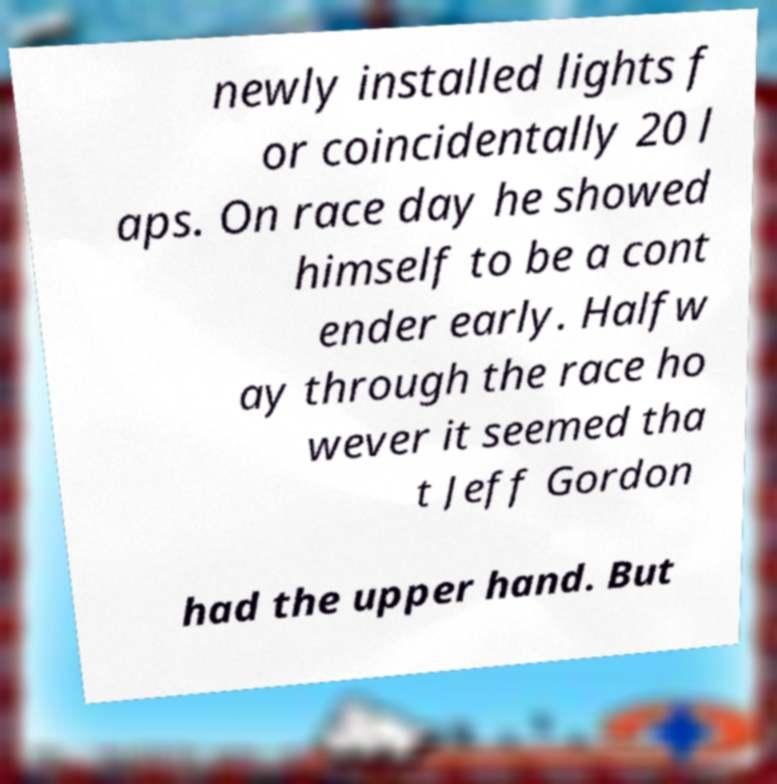Could you extract and type out the text from this image? newly installed lights f or coincidentally 20 l aps. On race day he showed himself to be a cont ender early. Halfw ay through the race ho wever it seemed tha t Jeff Gordon had the upper hand. But 